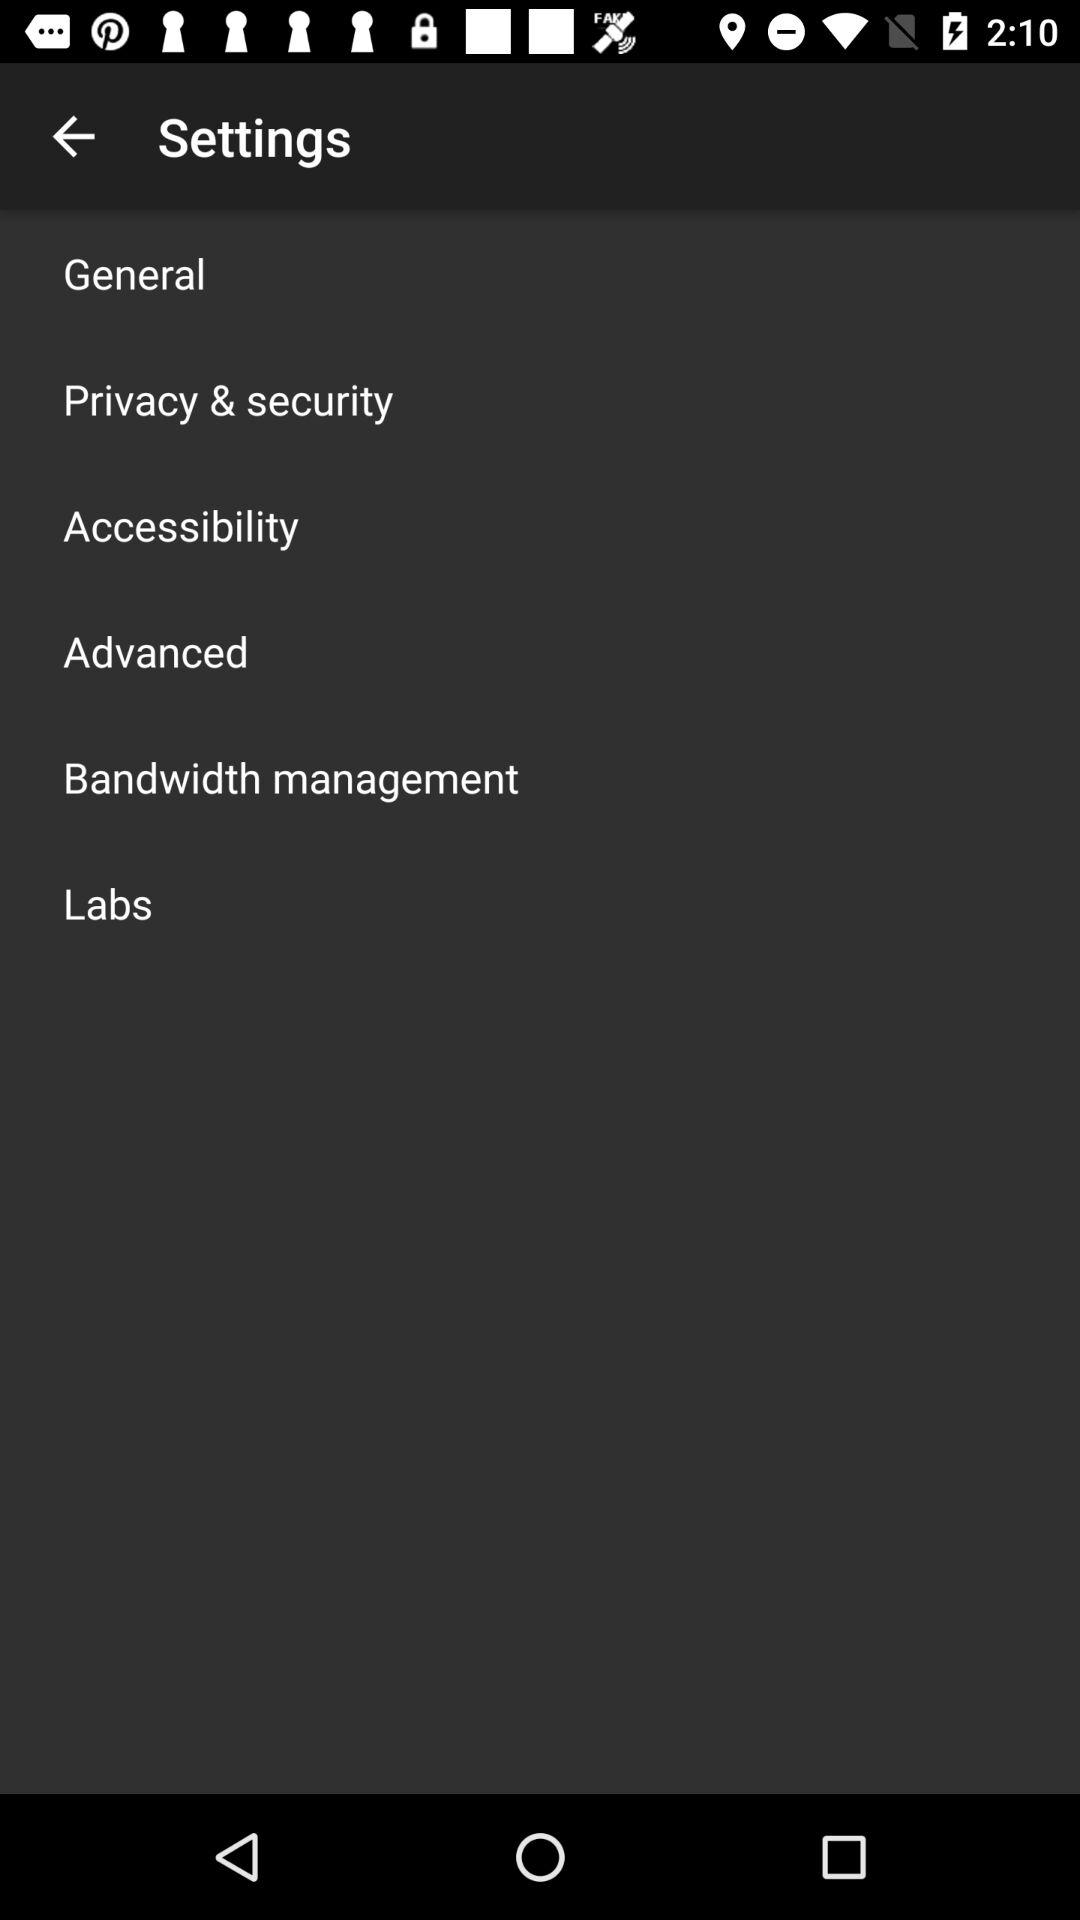How many items are in the settings menu?
Answer the question using a single word or phrase. 6 